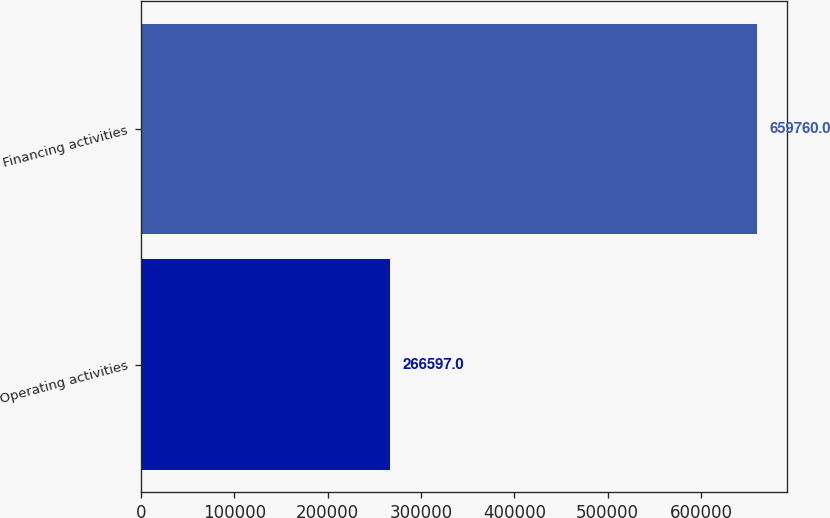<chart> <loc_0><loc_0><loc_500><loc_500><bar_chart><fcel>Operating activities<fcel>Financing activities<nl><fcel>266597<fcel>659760<nl></chart> 